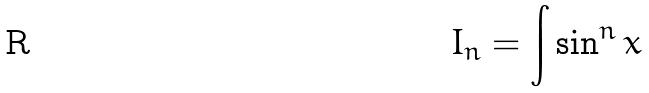Convert formula to latex. <formula><loc_0><loc_0><loc_500><loc_500>I _ { n } = \int \sin ^ { n } x</formula> 